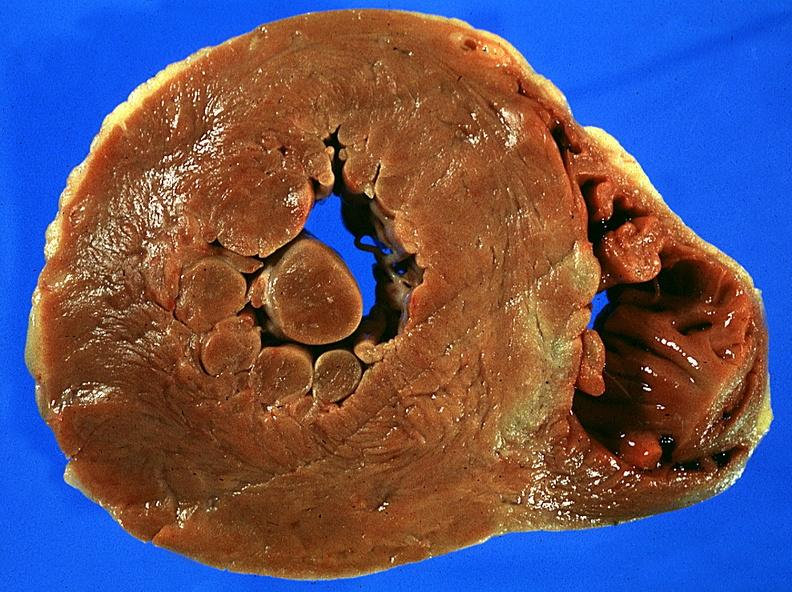does case of peritonitis slide show left ventricular hypertrophy?
Answer the question using a single word or phrase. No 